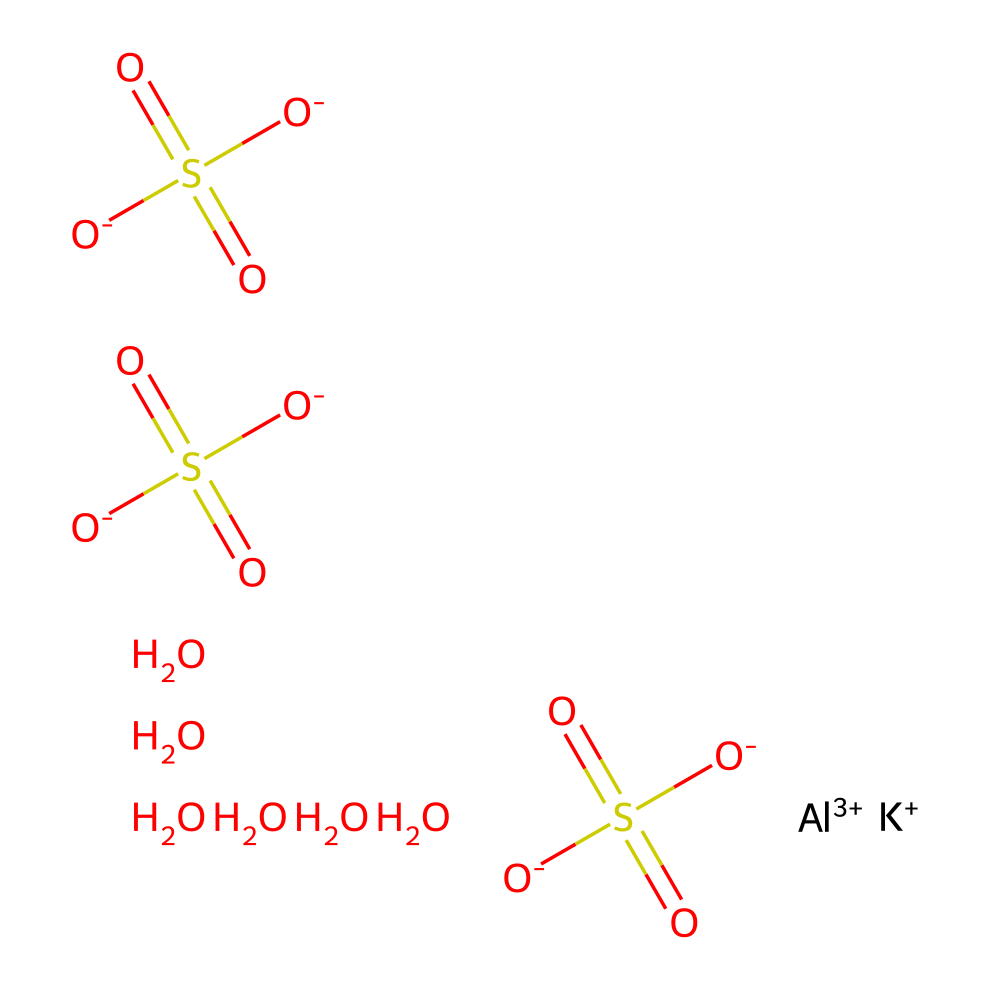What is the chemical name of the compound represented by this structure? The SMILES representation indicates the presence of aluminum (Al), potassium (K), and sulfate (SO4). Therefore, the name of the compound is aluminum potassium sulfate.
Answer: aluminum potassium sulfate How many sulfate groups are present in this compound? Analyzing the SMILES reveals that there are three occurrences of the sulfate unit (SO4) within the structure. Each sulfate group is represented by "S(=O)(=O)[O-]", thus totaling three groups.
Answer: 3 What is the oxidation state of aluminum in this coordination compound? By examining the initial part of the SMILES, it shows that aluminum is represented as [Al+3], indicating that it has a +3 oxidation state in this compound.
Answer: +3 How many total oxygen atoms are in this molecule? Counting from the SMILES, we have three sulfate groups that each contain four oxygen atoms (3 × 4 = 12) plus two additional oxygen atoms. Thus, the total sum is 12 + 2 = 14 oxygen atoms.
Answer: 14 What role does this compound play in fabric dyeing? Aluminum potassium sulfate is commonly used as a mordant in fabric dyeing, facilitating the binding of dye to the fabric, which enhances color adherence and quality.
Answer: mordant Which cation in this compound has a coordinating role? The chemical structure indicates that aluminum (Al) acts as the central metal ion and thus has a coordinating role in the formation of the coordination compound with the sulfate ligands.
Answer: aluminum 